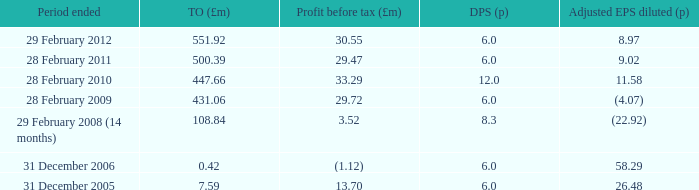What was the turnover when the profit before tax was 29.47? 500.39. 